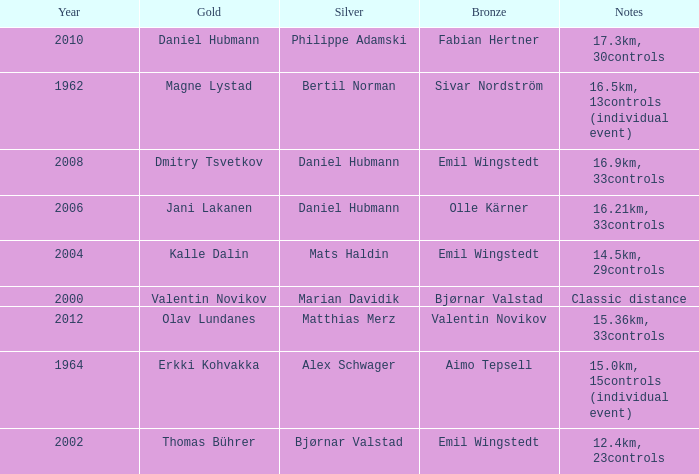WHAT IS THE YEAR WITH A BRONZE OF AIMO TEPSELL? 1964.0. 